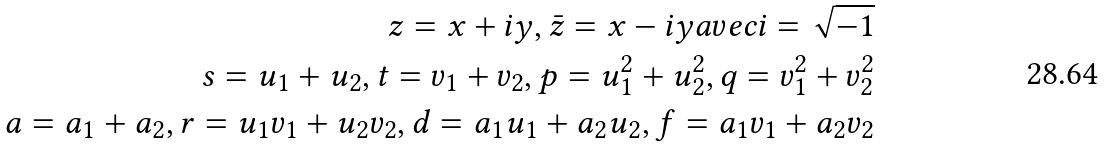Convert formula to latex. <formula><loc_0><loc_0><loc_500><loc_500>z = x + i y , \bar { z } = x - i y a v e c i = \sqrt { - 1 } \\ s = u _ { 1 } + u _ { 2 } , t = v _ { 1 } + v _ { 2 } , p = u _ { 1 } ^ { 2 } + u _ { 2 } ^ { 2 } , q = v _ { 1 } ^ { 2 } + v _ { 2 } ^ { 2 } \\ a = a _ { 1 } + a _ { 2 } , r = u _ { 1 } v _ { 1 } + u _ { 2 } v _ { 2 } , d = a _ { 1 } u _ { 1 } + a _ { 2 } u _ { 2 } , f = a _ { 1 } v _ { 1 } + a _ { 2 } v _ { 2 }</formula> 